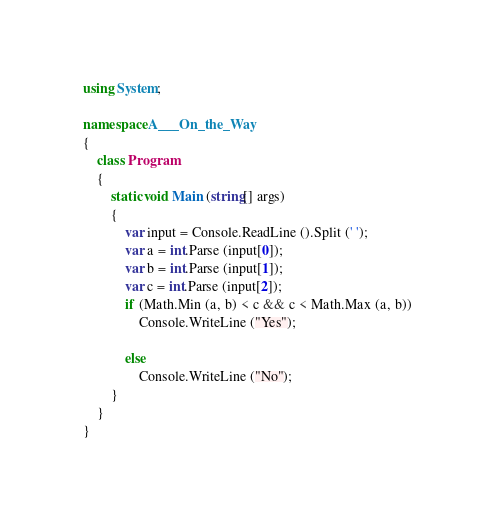Convert code to text. <code><loc_0><loc_0><loc_500><loc_500><_C#_>using System;

namespace A___On_the_Way
{
    class Program
    {
        static void Main (string[] args)
        {
            var input = Console.ReadLine ().Split (' ');
            var a = int.Parse (input[0]);
            var b = int.Parse (input[1]);
            var c = int.Parse (input[2]);
            if (Math.Min (a, b) < c && c < Math.Max (a, b))
                Console.WriteLine ("Yes");

            else
                Console.WriteLine ("No");
        }
    }
}</code> 